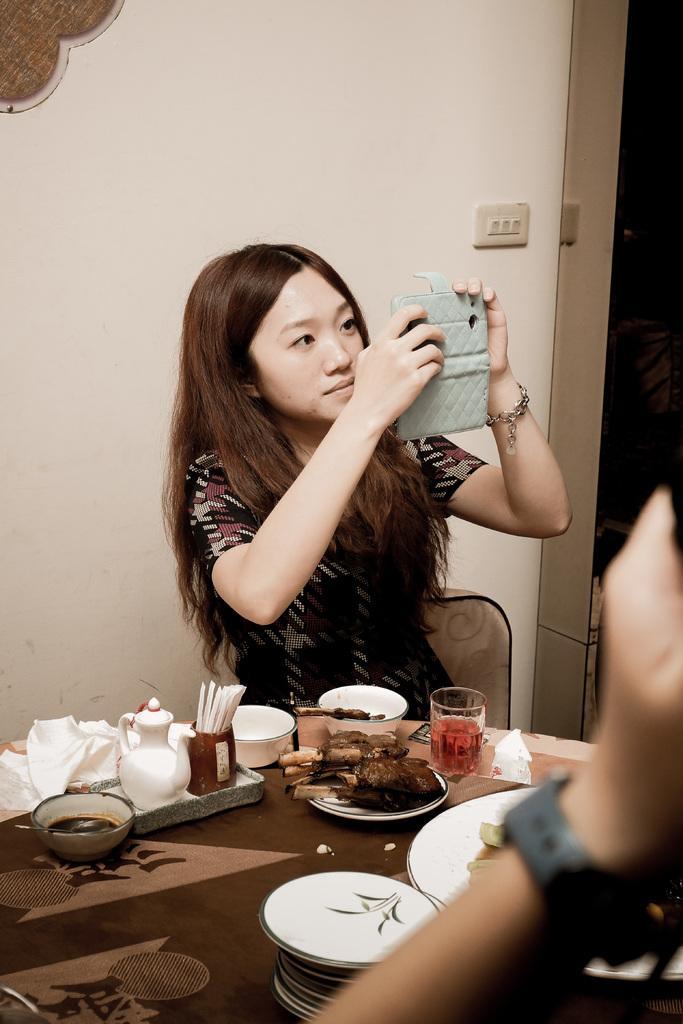In one or two sentences, can you explain what this image depicts? In this image i can see a woman sitting in front of the table ,on the table there are the plates and glass and drink and there are the food items kept on the table , a person holding a mobile phone on her hand ,back side of her there is a wall ,on the wall there are the switches visible and right side a person hand. 